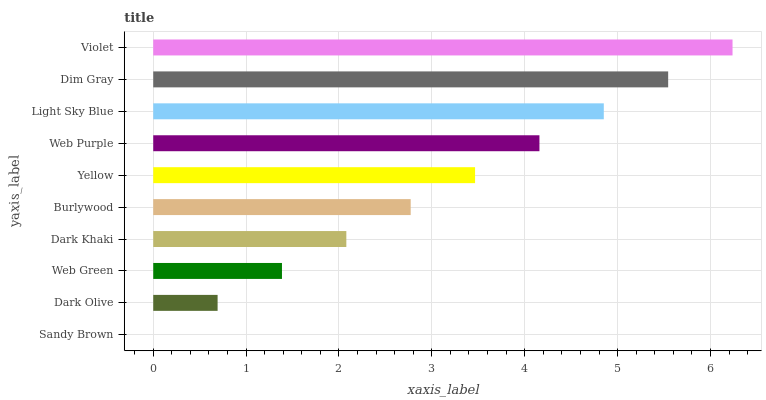Is Sandy Brown the minimum?
Answer yes or no. Yes. Is Violet the maximum?
Answer yes or no. Yes. Is Dark Olive the minimum?
Answer yes or no. No. Is Dark Olive the maximum?
Answer yes or no. No. Is Dark Olive greater than Sandy Brown?
Answer yes or no. Yes. Is Sandy Brown less than Dark Olive?
Answer yes or no. Yes. Is Sandy Brown greater than Dark Olive?
Answer yes or no. No. Is Dark Olive less than Sandy Brown?
Answer yes or no. No. Is Yellow the high median?
Answer yes or no. Yes. Is Burlywood the low median?
Answer yes or no. Yes. Is Burlywood the high median?
Answer yes or no. No. Is Sandy Brown the low median?
Answer yes or no. No. 